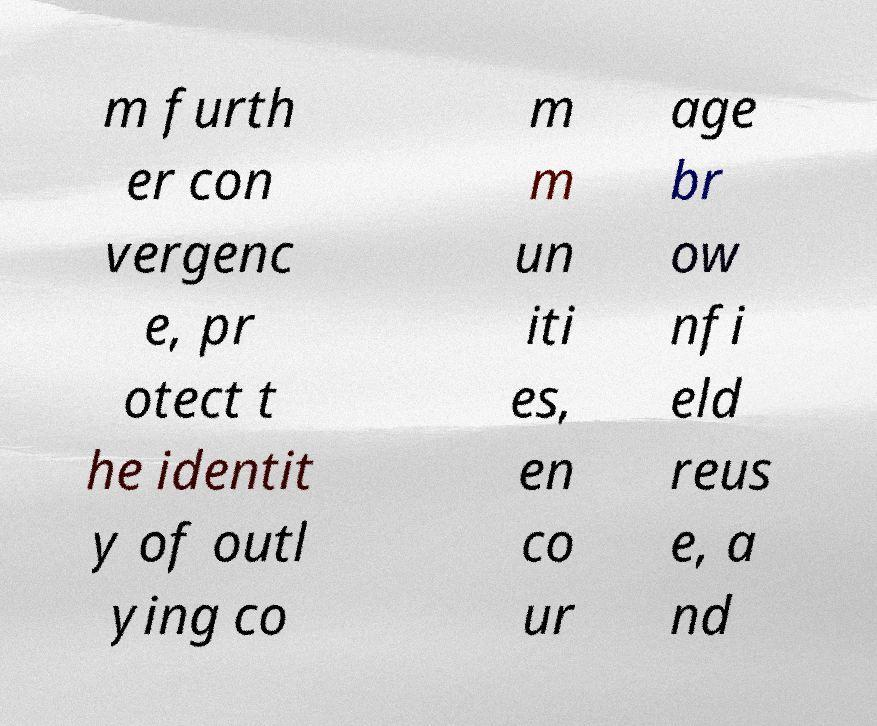What messages or text are displayed in this image? I need them in a readable, typed format. m furth er con vergenc e, pr otect t he identit y of outl ying co m m un iti es, en co ur age br ow nfi eld reus e, a nd 